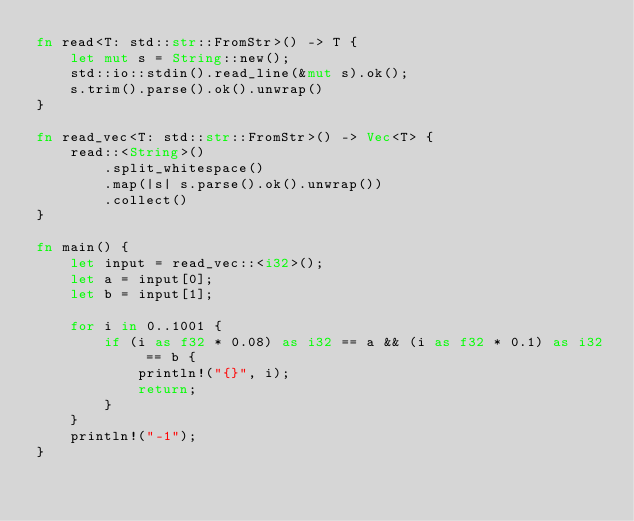<code> <loc_0><loc_0><loc_500><loc_500><_Rust_>fn read<T: std::str::FromStr>() -> T {
    let mut s = String::new();
    std::io::stdin().read_line(&mut s).ok();
    s.trim().parse().ok().unwrap()
}

fn read_vec<T: std::str::FromStr>() -> Vec<T> {
    read::<String>()
        .split_whitespace()
        .map(|s| s.parse().ok().unwrap())
        .collect()
}

fn main() {
    let input = read_vec::<i32>();
    let a = input[0];
    let b = input[1];

    for i in 0..1001 {
        if (i as f32 * 0.08) as i32 == a && (i as f32 * 0.1) as i32 == b {
            println!("{}", i);
            return;
        }
    }
    println!("-1");
}</code> 